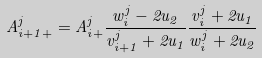<formula> <loc_0><loc_0><loc_500><loc_500>A ^ { j } _ { i + 1 + } = A ^ { j } _ { i + } \frac { w ^ { j } _ { i } - 2 u _ { 2 } } { v ^ { j } _ { i + 1 } + 2 u _ { 1 } } \frac { v ^ { j } _ { i } + 2 u _ { 1 } } { w ^ { j } _ { i } + 2 u _ { 2 } }</formula> 